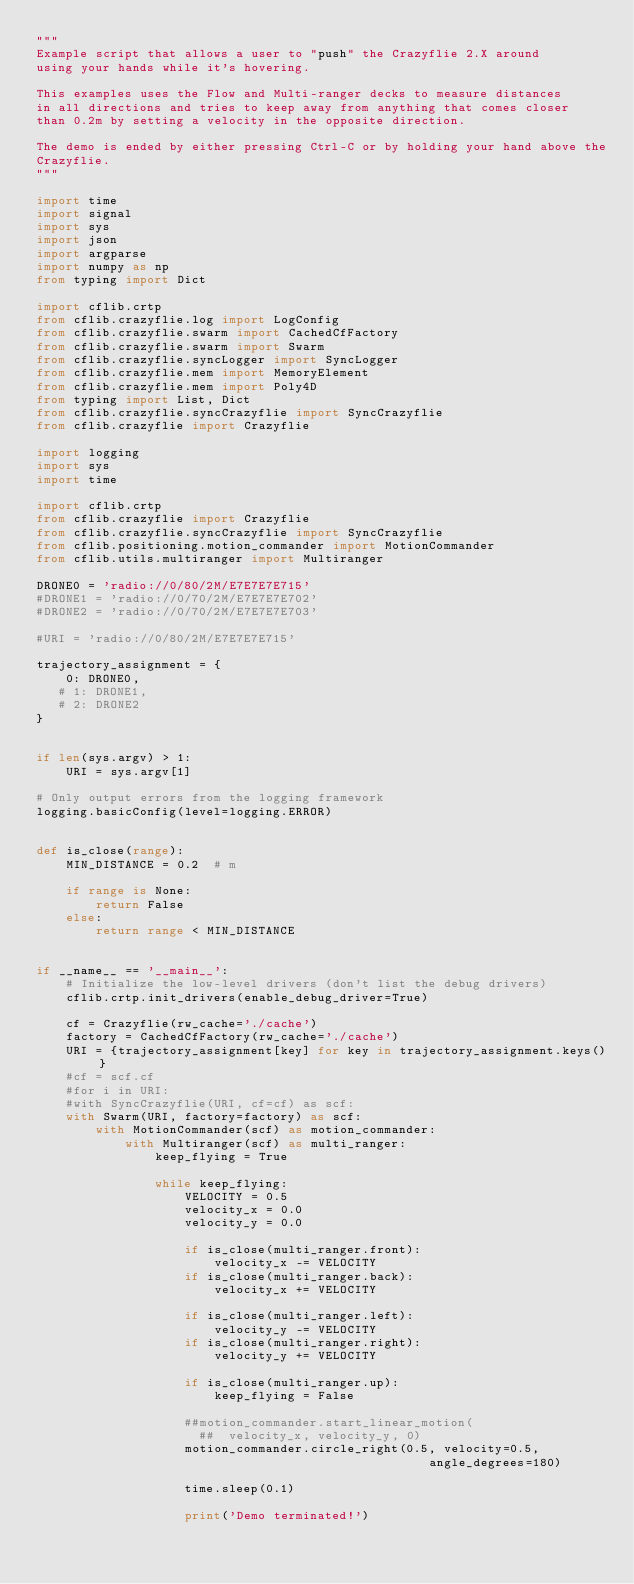<code> <loc_0><loc_0><loc_500><loc_500><_Python_>"""
Example script that allows a user to "push" the Crazyflie 2.X around
using your hands while it's hovering.

This examples uses the Flow and Multi-ranger decks to measure distances
in all directions and tries to keep away from anything that comes closer
than 0.2m by setting a velocity in the opposite direction.

The demo is ended by either pressing Ctrl-C or by holding your hand above the
Crazyflie.
"""

import time
import signal
import sys
import json
import argparse
import numpy as np
from typing import Dict

import cflib.crtp
from cflib.crazyflie.log import LogConfig
from cflib.crazyflie.swarm import CachedCfFactory
from cflib.crazyflie.swarm import Swarm
from cflib.crazyflie.syncLogger import SyncLogger
from cflib.crazyflie.mem import MemoryElement
from cflib.crazyflie.mem import Poly4D
from typing import List, Dict
from cflib.crazyflie.syncCrazyflie import SyncCrazyflie
from cflib.crazyflie import Crazyflie

import logging
import sys
import time

import cflib.crtp
from cflib.crazyflie import Crazyflie
from cflib.crazyflie.syncCrazyflie import SyncCrazyflie
from cflib.positioning.motion_commander import MotionCommander
from cflib.utils.multiranger import Multiranger

DRONE0 = 'radio://0/80/2M/E7E7E7E715'
#DRONE1 = 'radio://0/70/2M/E7E7E7E702'
#DRONE2 = 'radio://0/70/2M/E7E7E7E703'

#URI = 'radio://0/80/2M/E7E7E7E715'

trajectory_assignment = {
    0: DRONE0,
   # 1: DRONE1,
   # 2: DRONE2
}


if len(sys.argv) > 1:
    URI = sys.argv[1]

# Only output errors from the logging framework
logging.basicConfig(level=logging.ERROR)


def is_close(range):
    MIN_DISTANCE = 0.2  # m

    if range is None:
        return False
    else:
        return range < MIN_DISTANCE


if __name__ == '__main__':
    # Initialize the low-level drivers (don't list the debug drivers)
    cflib.crtp.init_drivers(enable_debug_driver=True)

    cf = Crazyflie(rw_cache='./cache')
    factory = CachedCfFactory(rw_cache='./cache')
    URI = {trajectory_assignment[key] for key in trajectory_assignment.keys()}
    #cf = scf.cf
    #for i in URI:
    #with SyncCrazyflie(URI, cf=cf) as scf:
    with Swarm(URI, factory=factory) as scf:
        with MotionCommander(scf) as motion_commander:
            with Multiranger(scf) as multi_ranger:
                keep_flying = True

                while keep_flying:
                    VELOCITY = 0.5
                    velocity_x = 0.0
                    velocity_y = 0.0

                    if is_close(multi_ranger.front):
                        velocity_x -= VELOCITY
                    if is_close(multi_ranger.back):
                        velocity_x += VELOCITY

                    if is_close(multi_ranger.left):
                        velocity_y -= VELOCITY
                    if is_close(multi_ranger.right):
                        velocity_y += VELOCITY

                    if is_close(multi_ranger.up):
                        keep_flying = False

                    ##motion_commander.start_linear_motion(
                      ##  velocity_x, velocity_y, 0)
                    motion_commander.circle_right(0.5, velocity=0.5,
                                                     angle_degrees=180)
                      
                    time.sleep(0.1)

                    print('Demo terminated!')
</code> 